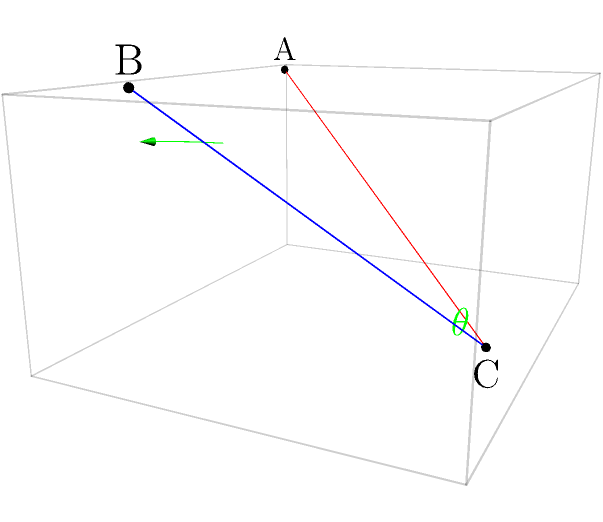In the Codford Village Hall theatre, two spotlights are positioned at points A and B on the lighting rig, both directed at point C on the stage floor. If the coordinates of these points in meters are A(2,1,5), B(8,1,5), and C(5,7,0), what is the angle $\theta$ between the two spotlight beams? To find the angle between the two spotlights, we can use the dot product formula for the angle between two vectors. Let's approach this step-by-step:

1) First, we need to create vectors for each spotlight beam:
   $\vec{AC} = C - A = (5,7,0) - (2,1,5) = (3,6,-5)$
   $\vec{BC} = C - B = (5,7,0) - (8,1,5) = (-3,6,-5)$

2) The formula for the angle between two vectors $\vec{u}$ and $\vec{v}$ is:
   $\cos \theta = \frac{\vec{u} \cdot \vec{v}}{|\vec{u}||\vec{v}|}$

3) Let's calculate the dot product $\vec{AC} \cdot \vec{BC}$:
   $(3,6,-5) \cdot (-3,6,-5) = -9 + 36 + 25 = 52$

4) Now, let's calculate the magnitudes:
   $|\vec{AC}| = \sqrt{3^2 + 6^2 + (-5)^2} = \sqrt{70}$
   $|\vec{BC}| = \sqrt{(-3)^2 + 6^2 + (-5)^2} = \sqrt{70}$

5) Plugging into our formula:
   $\cos \theta = \frac{52}{\sqrt{70} \cdot \sqrt{70}} = \frac{52}{70} = \frac{26}{35}$

6) To get $\theta$, we take the inverse cosine (arccos):
   $\theta = \arccos(\frac{26}{35}) \approx 0.8621$ radians

7) Converting to degrees:
   $\theta \approx 0.8621 \cdot \frac{180}{\pi} \approx 49.4°$
Answer: $49.4°$ 